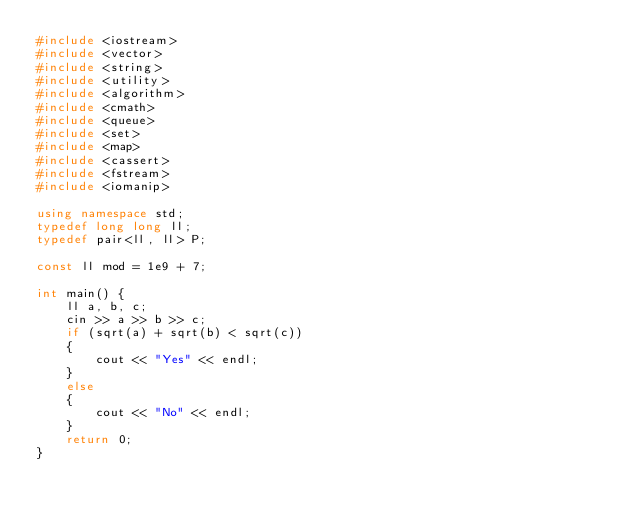Convert code to text. <code><loc_0><loc_0><loc_500><loc_500><_C++_>#include <iostream>
#include <vector>
#include <string>
#include <utility>
#include <algorithm>
#include <cmath>
#include <queue>
#include <set>
#include <map>
#include <cassert>
#include <fstream>
#include <iomanip>

using namespace std;
typedef long long ll;
typedef pair<ll, ll> P;

const ll mod = 1e9 + 7;

int main() {
    ll a, b, c;
    cin >> a >> b >> c;
    if (sqrt(a) + sqrt(b) < sqrt(c))
    {
        cout << "Yes" << endl;
    }
    else
    {
        cout << "No" << endl;
    }
    return 0;
}</code> 